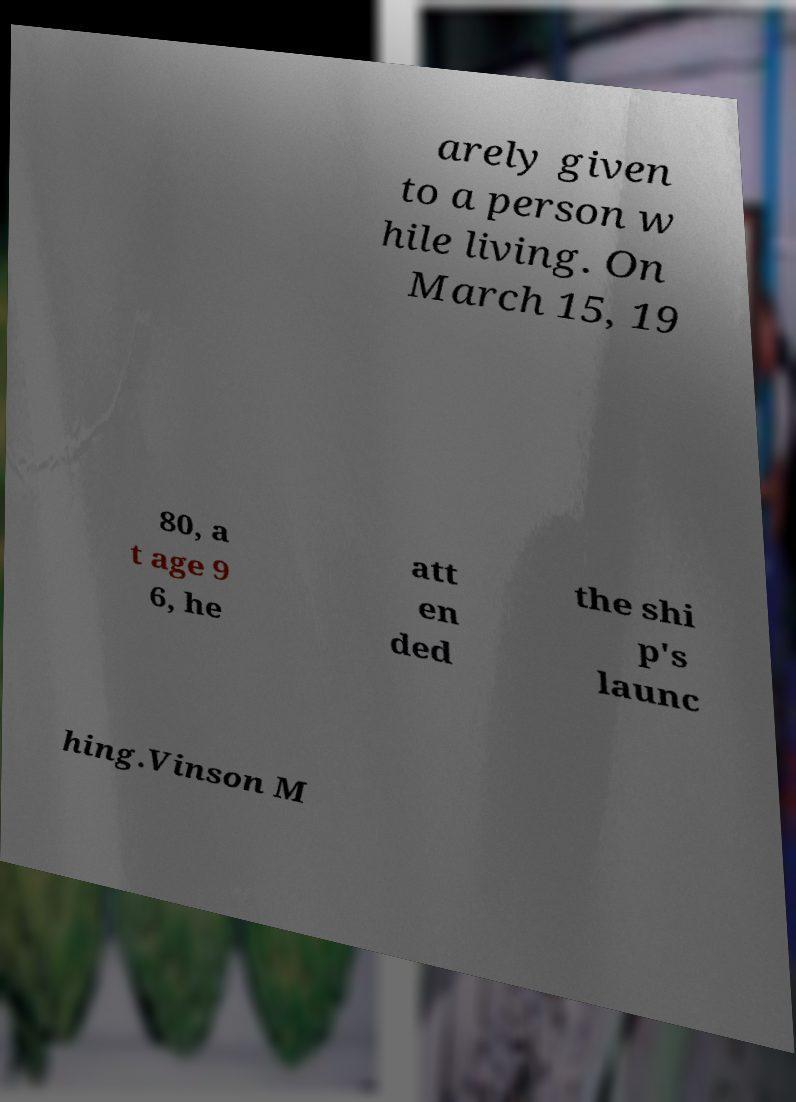What messages or text are displayed in this image? I need them in a readable, typed format. arely given to a person w hile living. On March 15, 19 80, a t age 9 6, he att en ded the shi p's launc hing.Vinson M 